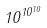Convert formula to latex. <formula><loc_0><loc_0><loc_500><loc_500>1 0 ^ { 1 0 ^ { 1 0 } }</formula> 